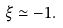Convert formula to latex. <formula><loc_0><loc_0><loc_500><loc_500>\xi \simeq - 1 .</formula> 